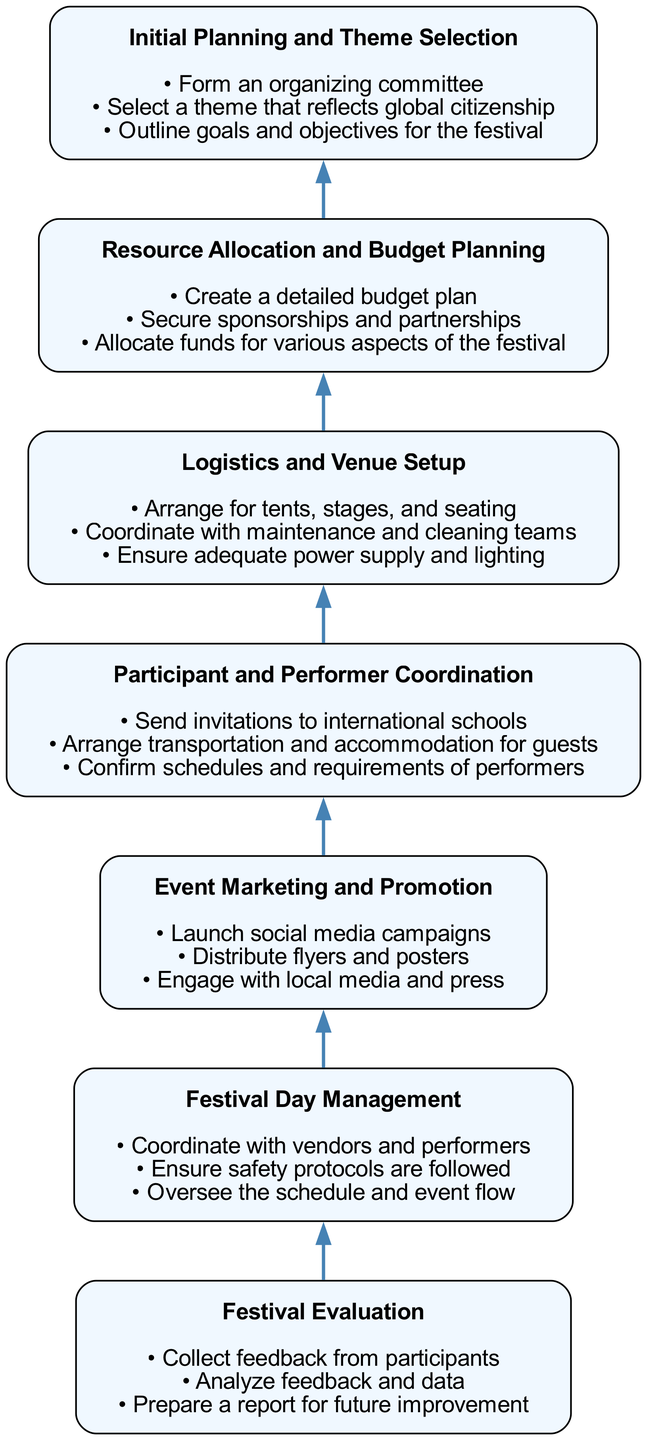What is the first step in organizing the festival? The first step in the diagram is labeled "Initial Planning and Theme Selection," which is the bottommost node representing the beginning of the process.
Answer: Initial Planning and Theme Selection How many responsibilities are associated with "Logistics and Venue Setup"? The "Logistics and Venue Setup" step lists three responsibilities, which can be counted by reviewing the bullet points under that step.
Answer: 3 Which step comes after "Resource Allocation and Budget Planning"? By looking at the flow of the diagram, we see that "Festival Day Management" is connected to "Resource Allocation and Budget Planning" as the next step up in the flow.
Answer: Festival Day Management What is one responsibility of the "Event Marketing and Promotion"? The responsibilities listed under "Event Marketing and Promotion" include "Launch social media campaigns," which can be identified directly from the diagram's relevant node.
Answer: Launch social media campaigns What are the last two steps in the process? By examining the diagram flow, the last two steps listed are "Festival Day Management" and "Festival Evaluation," as they are the top two nodes in the upward flow.
Answer: Festival Day Management, Festival Evaluation How is "Participant and Performer Coordination" related to "Festival Evaluation"? The diagram shows a sequential connection where "Participant and Performer Coordination" is a step before "Festival Evaluation," indicating that coordination of participants and performers occurs prior to evaluating the festival.
Answer: "Participant and Performer Coordination" is before "Festival Evaluation" What does the theme selected in "Initial Planning and Theme Selection" reflect? The diagram specifies that the theme selected should reflect "global citizenship," highlighting the festival's emphasis on multicultural participation.
Answer: Global citizenship How many steps are there in total? Counting the nodes listed from the bottom to the top of the flowchart gives a total of seven distinct steps outlined in the diagram.
Answer: 7 